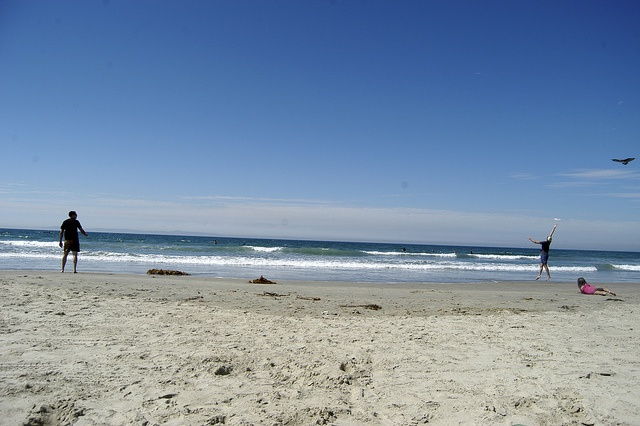Describe the objects in this image and their specific colors. I can see people in blue, black, darkgray, and navy tones, people in blue, black, darkgray, gray, and navy tones, people in blue, black, purple, and gray tones, bird in blue, black, navy, and gray tones, and frisbee in blue, darkgray, and lightgray tones in this image. 